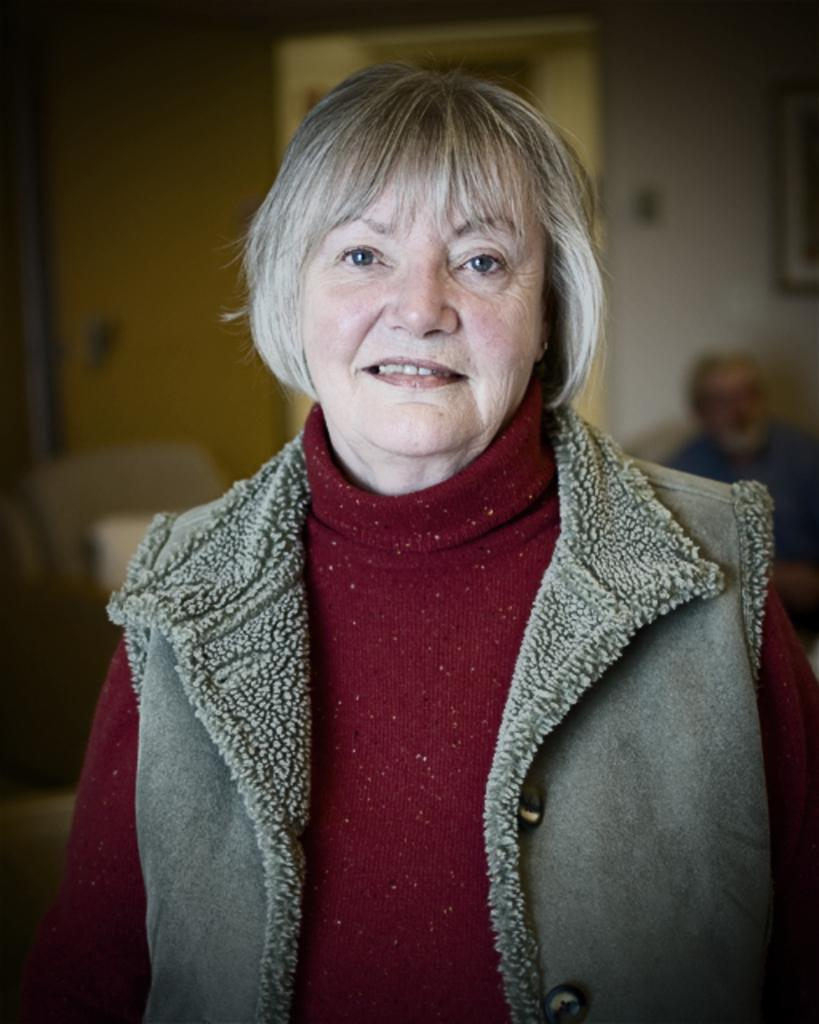Who is present in the image? There is a woman and a man sitting in the image. What is the man doing in the image? The man is sitting in the image. What architectural features can be seen in the image? There is a door and a wall in the image. What type of hose is being used to clean the floor in the image? A: There is no hose present in the image, and the floor is not being cleaned. 